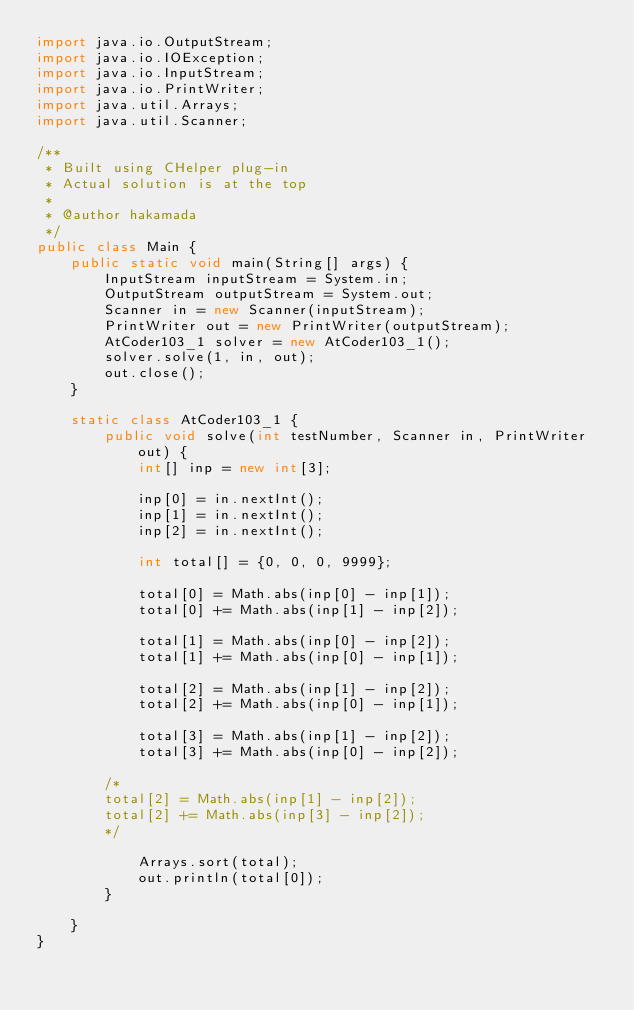Convert code to text. <code><loc_0><loc_0><loc_500><loc_500><_Java_>import java.io.OutputStream;
import java.io.IOException;
import java.io.InputStream;
import java.io.PrintWriter;
import java.util.Arrays;
import java.util.Scanner;

/**
 * Built using CHelper plug-in
 * Actual solution is at the top
 *
 * @author hakamada
 */
public class Main {
    public static void main(String[] args) {
        InputStream inputStream = System.in;
        OutputStream outputStream = System.out;
        Scanner in = new Scanner(inputStream);
        PrintWriter out = new PrintWriter(outputStream);
        AtCoder103_1 solver = new AtCoder103_1();
        solver.solve(1, in, out);
        out.close();
    }

    static class AtCoder103_1 {
        public void solve(int testNumber, Scanner in, PrintWriter out) {
            int[] inp = new int[3];

            inp[0] = in.nextInt();
            inp[1] = in.nextInt();
            inp[2] = in.nextInt();

            int total[] = {0, 0, 0, 9999};

            total[0] = Math.abs(inp[0] - inp[1]);
            total[0] += Math.abs(inp[1] - inp[2]);

            total[1] = Math.abs(inp[0] - inp[2]);
            total[1] += Math.abs(inp[0] - inp[1]);

            total[2] = Math.abs(inp[1] - inp[2]);
            total[2] += Math.abs(inp[0] - inp[1]);

            total[3] = Math.abs(inp[1] - inp[2]);
            total[3] += Math.abs(inp[0] - inp[2]);

        /*
        total[2] = Math.abs(inp[1] - inp[2]);
        total[2] += Math.abs(inp[3] - inp[2]);
        */

            Arrays.sort(total);
            out.println(total[0]);
        }

    }
}

</code> 